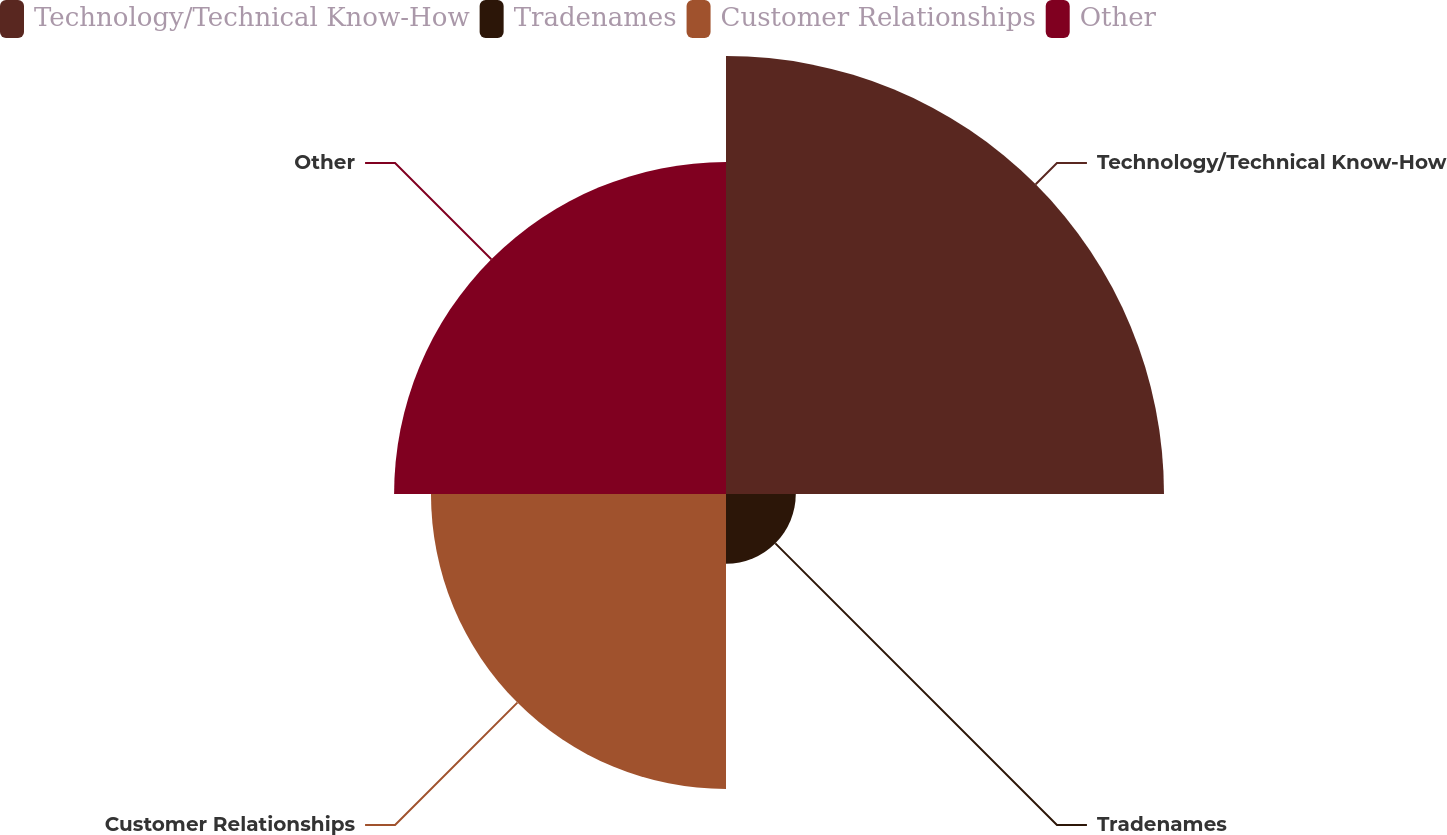Convert chart. <chart><loc_0><loc_0><loc_500><loc_500><pie_chart><fcel>Technology/Technical Know-How<fcel>Tradenames<fcel>Customer Relationships<fcel>Other<nl><fcel>38.6%<fcel>6.15%<fcel>26.0%<fcel>29.25%<nl></chart> 